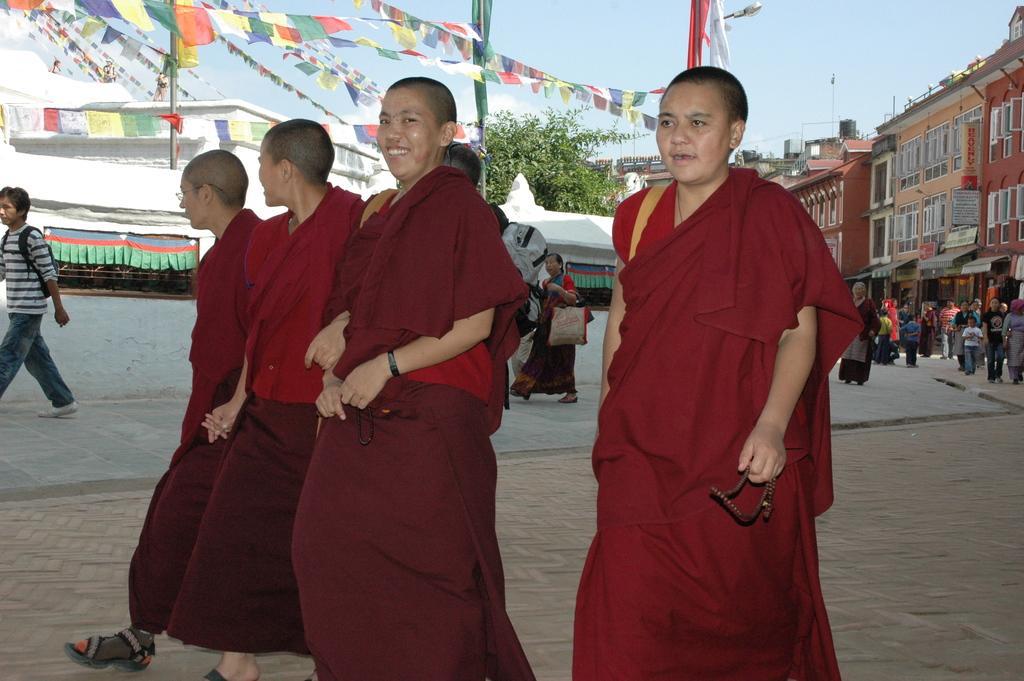Describe this image in one or two sentences. In this image in the front there are persons standing and smiling. In the background there are tents, buildings and there are flags, poles, there is a tree and there are persons. 